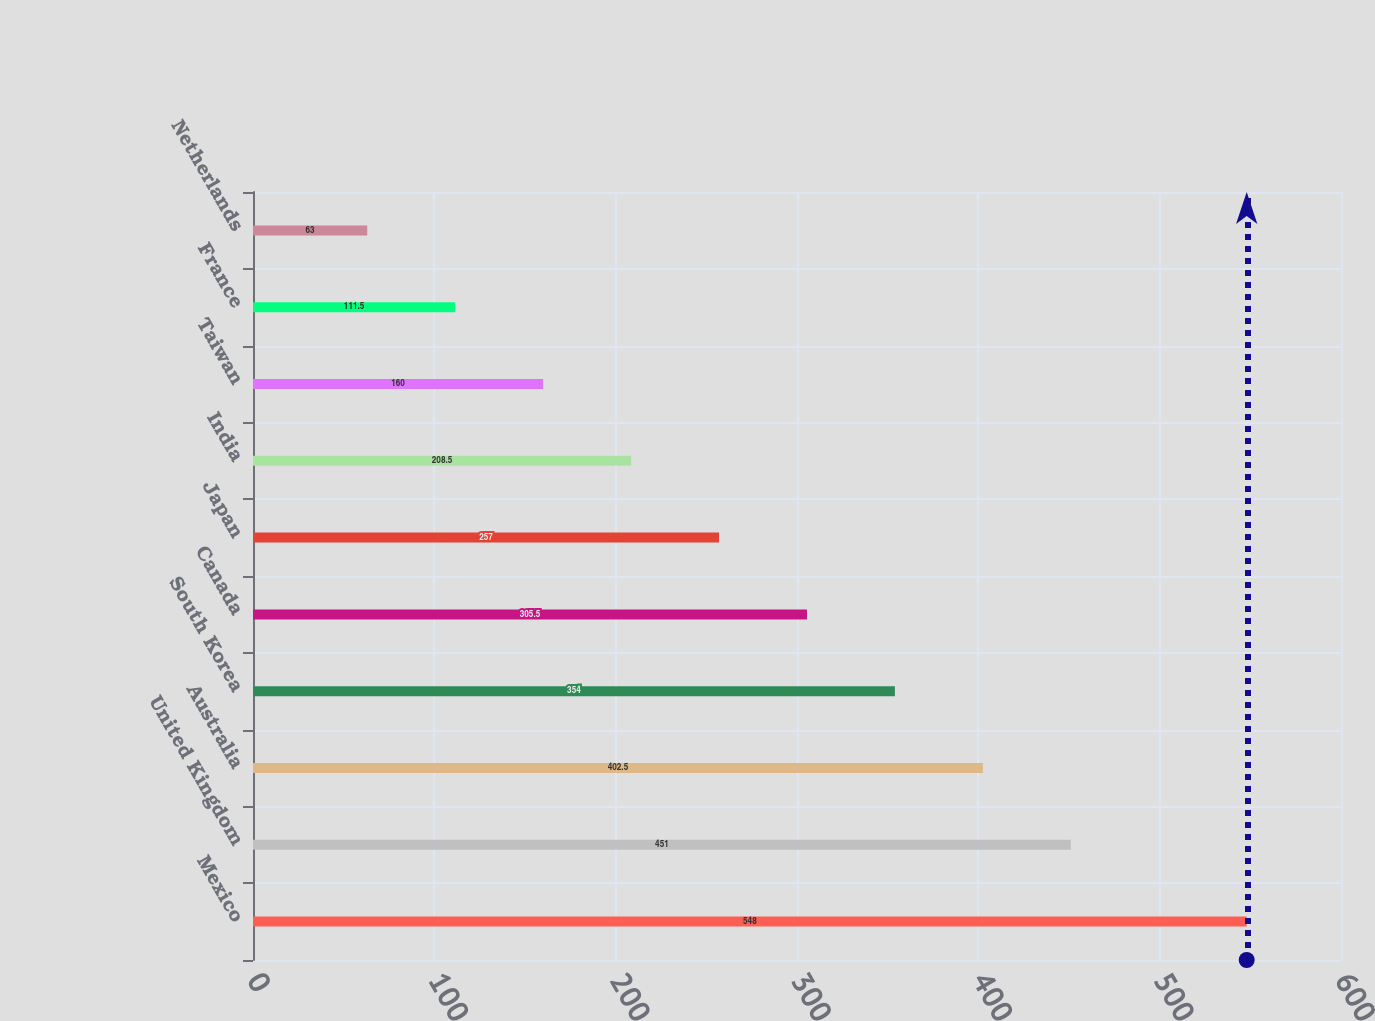Convert chart to OTSL. <chart><loc_0><loc_0><loc_500><loc_500><bar_chart><fcel>Mexico<fcel>United Kingdom<fcel>Australia<fcel>South Korea<fcel>Canada<fcel>Japan<fcel>India<fcel>Taiwan<fcel>France<fcel>Netherlands<nl><fcel>548<fcel>451<fcel>402.5<fcel>354<fcel>305.5<fcel>257<fcel>208.5<fcel>160<fcel>111.5<fcel>63<nl></chart> 